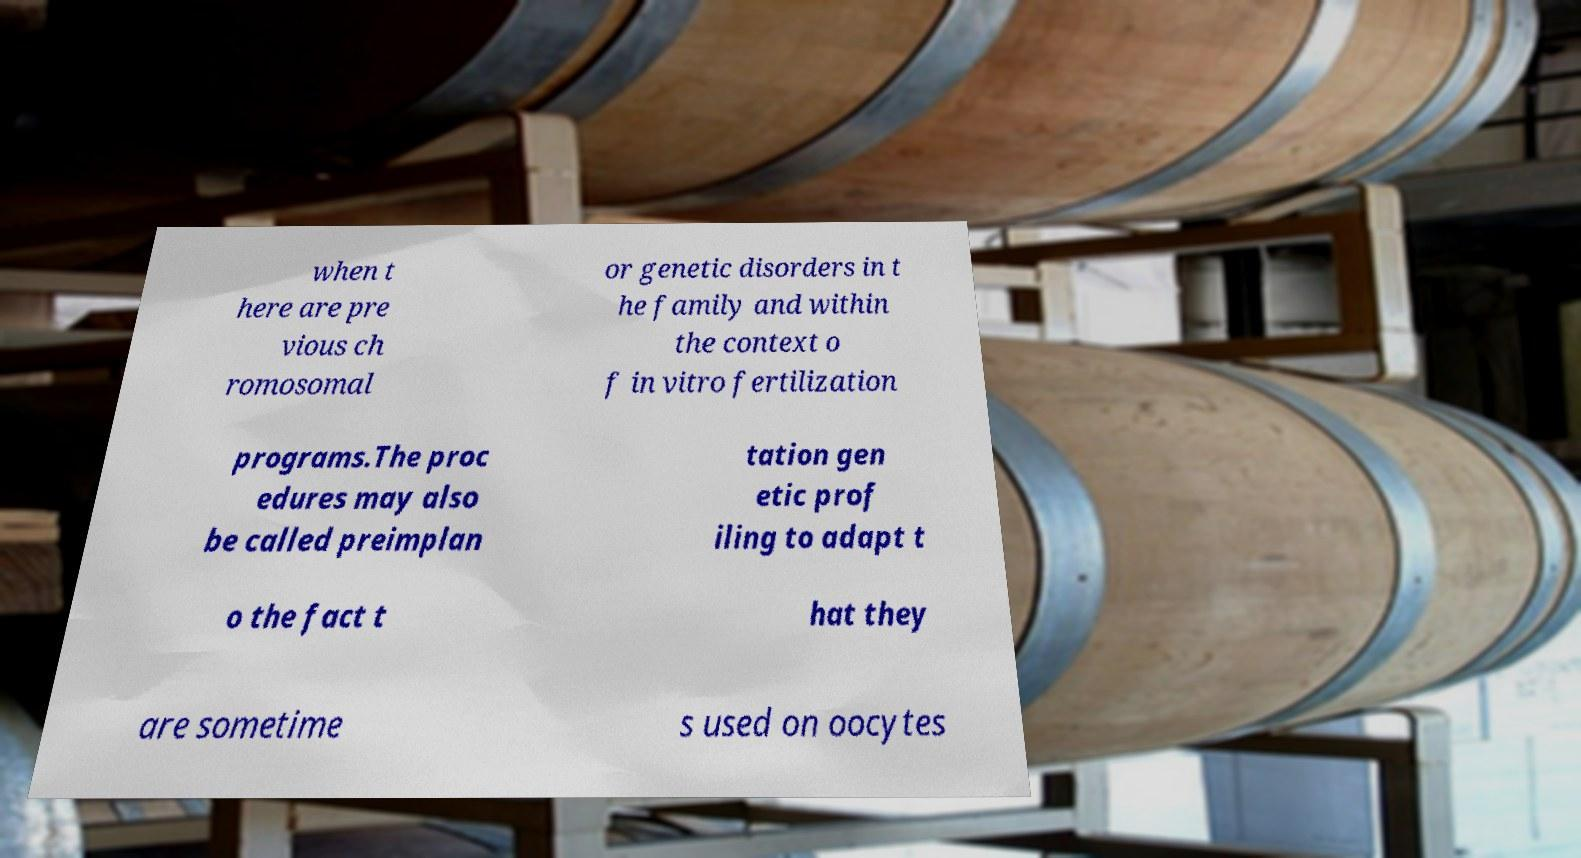I need the written content from this picture converted into text. Can you do that? when t here are pre vious ch romosomal or genetic disorders in t he family and within the context o f in vitro fertilization programs.The proc edures may also be called preimplan tation gen etic prof iling to adapt t o the fact t hat they are sometime s used on oocytes 